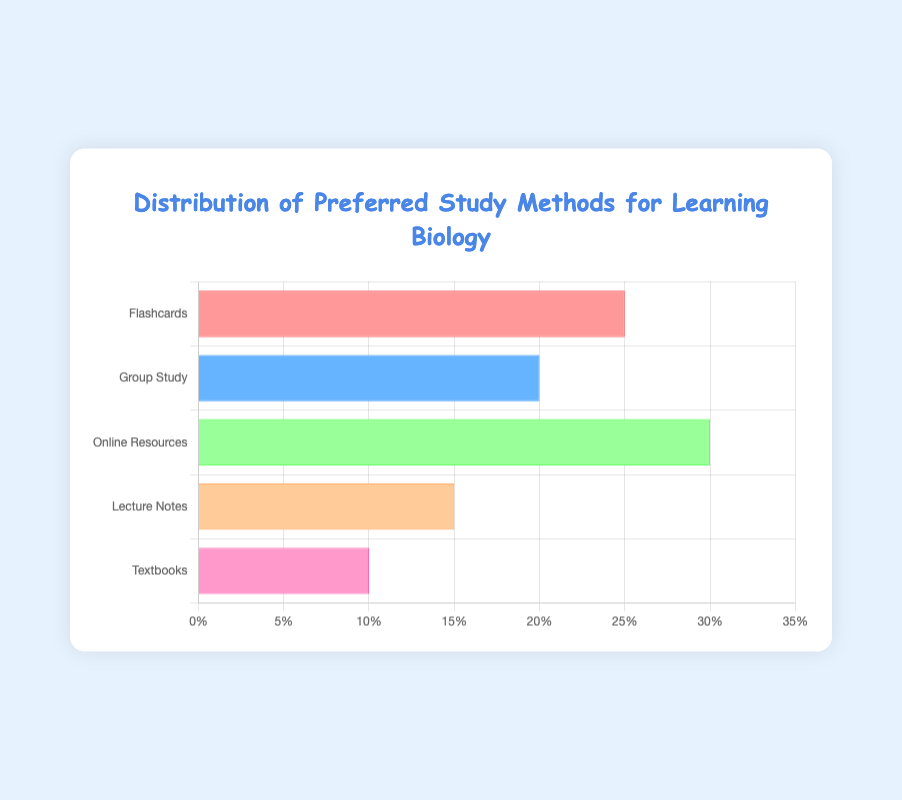What study method shows the highest preference among students? The study method with the highest preference can be identified by looking at the longest bar on the chart. In this case, the "Online Resources" bar is the longest.
Answer: Online Resources Which study method is preferred more: Flashcards or Textbooks? To answer this, compare the bar lengths for "Flashcards" and "Textbooks". Flashcards have a preference of 25%, while Textbooks have 10%.
Answer: Flashcards What’s the total percentage of students who prefer either Flashcards or Online Resources for learning biology? Sum the percentages for Flashcards and Online Resources: 25% + 30% = 55%.
Answer: 55% How much more popular are Online Resources compared to Lecture Notes? Find the difference in percentages between Online Resources and Lecture Notes: 30% - 15% = 15%.
Answer: 15% What is the combined preference percentage for Flashcards, Group Study, and Lecture Notes? Sum the percentages for Flashcards, Group Study, and Lecture Notes: 25% + 20% + 15% = 60%.
Answer: 60% Which study method has the lowest preference and what is the percentage? Identify the bar with the shortest length. The shortest bar corresponds to Textbooks, which has a preference of 10%.
Answer: Textbooks, 10% Are Group Study and Online Resources equally preferred? Compare the bar lengths for Group Study and Online Resources. Group Study has 20% preference, and Online Resources has 30%. They are not equally preferred.
Answer: No What method ranks second in terms of student preference? The method with the second longest bar (after Online Resources) is Flashcards, which has a 25% preference.
Answer: Flashcards What is the average percentage preference for all study methods shown? Calculate the mean of all percentages: (25% + 20% + 30% + 15% + 10%) / 5 = 100% / 5 = 20%.
Answer: 20% What's the difference in preference percentages between the most popular and the least popular study methods? The most popular method (Online Resources) has 30%, and the least popular method (Textbooks) has 10%. The difference is 30% - 10% = 20%.
Answer: 20% 